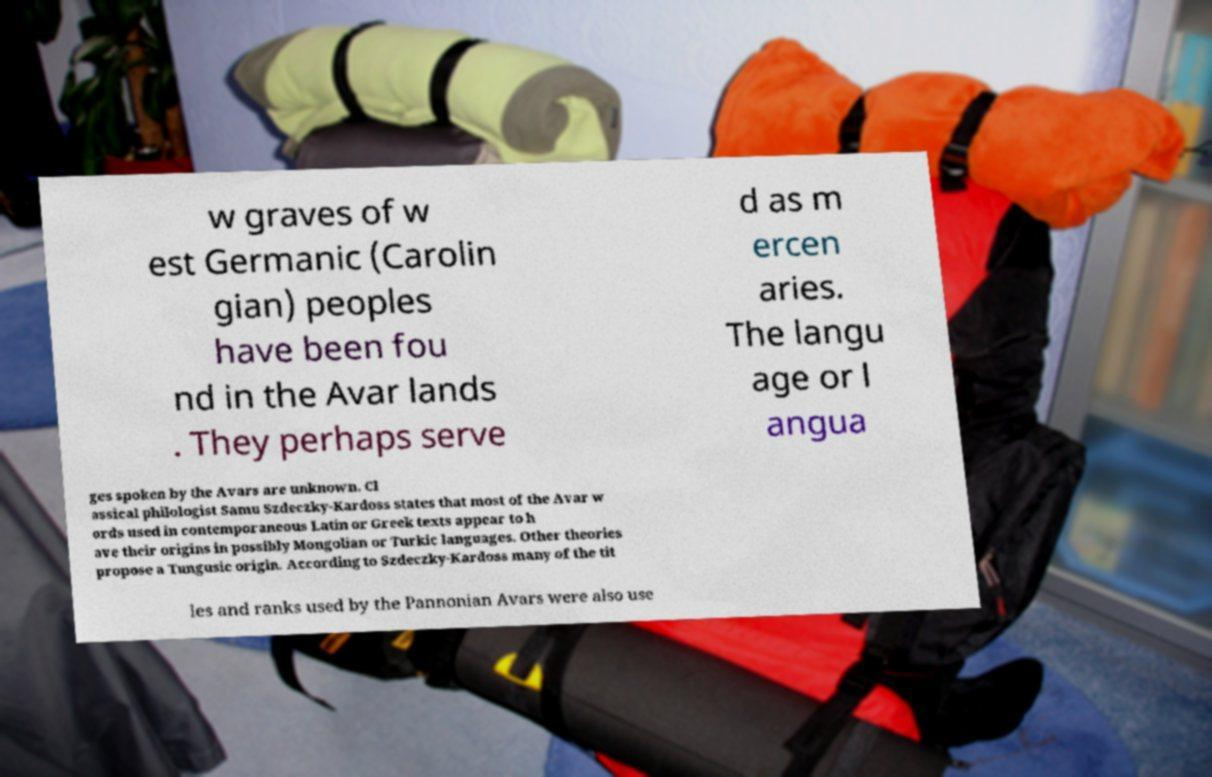Could you assist in decoding the text presented in this image and type it out clearly? w graves of w est Germanic (Carolin gian) peoples have been fou nd in the Avar lands . They perhaps serve d as m ercen aries. The langu age or l angua ges spoken by the Avars are unknown. Cl assical philologist Samu Szdeczky-Kardoss states that most of the Avar w ords used in contemporaneous Latin or Greek texts appear to h ave their origins in possibly Mongolian or Turkic languages. Other theories propose a Tungusic origin. According to Szdeczky-Kardoss many of the tit les and ranks used by the Pannonian Avars were also use 